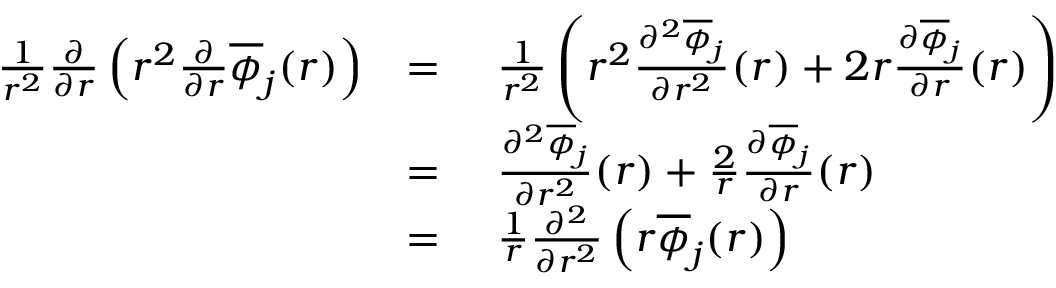Convert formula to latex. <formula><loc_0><loc_0><loc_500><loc_500>\begin{array} { r l r l } & { \frac { 1 } { r ^ { 2 } } \frac { \partial } { \partial r } \left ( r ^ { 2 } \frac { \partial } { \partial r } \overline { \phi } _ { j } ( r ) \right ) } & { = } & { \ \frac { 1 } { r ^ { 2 } } \left ( r ^ { 2 } \frac { \partial ^ { 2 } \overline { \phi } _ { j } } { \partial r ^ { 2 } } ( r ) + 2 r \frac { \partial \overline { \phi } _ { j } } { \partial r } ( r ) \right ) } \\ & { = } & { \ \frac { \partial ^ { 2 } \overline { \phi } _ { j } } { \partial r ^ { 2 } } ( r ) + \frac { 2 } { r } \frac { \partial \overline { \phi } _ { j } } { \partial r } ( r ) } \\ & { = } & { \ \frac { 1 } { r } \frac { \partial ^ { 2 } } { \partial r ^ { 2 } } \left ( r \overline { \phi } _ { j } ( r ) \right ) } \end{array}</formula> 